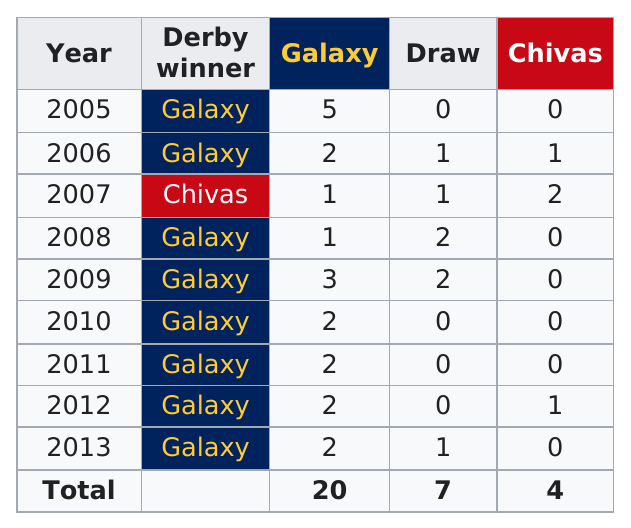Identify some key points in this picture. The first matchup in 2005 was between the Galaxy and who? There have been fewer than 10 draws in the history of the derby. The Galaxy has won the derby a total of eight times. The years are in consecutive order. In 2005, the galaxy scored either more or fewer than 3 goals. 